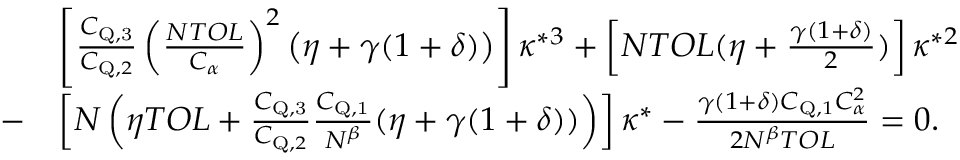<formula> <loc_0><loc_0><loc_500><loc_500>\begin{array} { r l } & { \left [ \frac { C _ { { Q } , 3 } } { C _ { Q , 2 } } \left ( \frac { N T O L } { C _ { \alpha } } \right ) ^ { 2 } \left ( \eta + \gamma ( 1 + \delta ) \right ) \right ] \kappa ^ { \ast 3 } + \left [ N T O L ( \eta + \frac { \gamma ( 1 + \delta ) } { 2 } ) \right ] \kappa ^ { \ast 2 } } \\ { - } & { \left [ N \left ( \eta T O L + \frac { C _ { { Q } , 3 } } { C _ { Q , 2 } } \frac { C _ { { Q } , 1 } } { N ^ { \beta } } ( \eta + \gamma ( 1 + \delta ) ) \right ) \right ] \kappa ^ { \ast } - \frac { \gamma ( 1 + \delta ) C _ { Q , 1 } C _ { \alpha } ^ { 2 } } { 2 N ^ { \beta } T O L } = 0 . } \end{array}</formula> 